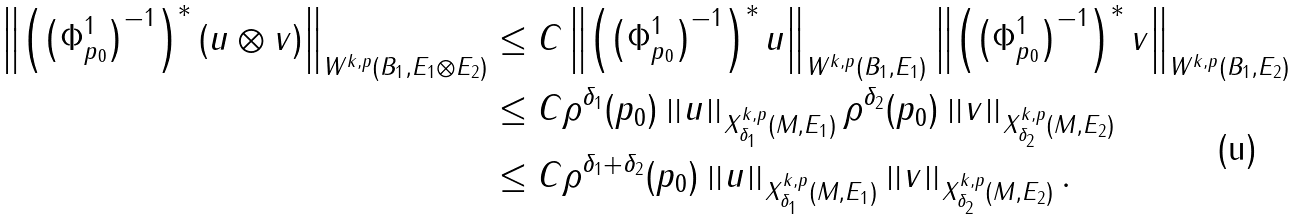<formula> <loc_0><loc_0><loc_500><loc_500>\left \| \left ( \left ( \Phi ^ { 1 } _ { p _ { 0 } } \right ) ^ { - 1 } \right ) ^ { * } ( u \otimes v ) \right \| _ { W ^ { k , p } ( B _ { 1 } , E _ { 1 } \otimes E _ { 2 } ) } & \leq C \left \| \left ( \left ( \Phi ^ { 1 } _ { p _ { 0 } } \right ) ^ { - 1 } \right ) ^ { * } u \right \| _ { W ^ { k , p } ( B _ { 1 } , E _ { 1 } ) } \left \| \left ( \left ( \Phi ^ { 1 } _ { p _ { 0 } } \right ) ^ { - 1 } \right ) ^ { * } v \right \| _ { W ^ { k , p } ( B _ { 1 } , E _ { 2 } ) } \\ & \leq C \rho ^ { \delta _ { 1 } } ( p _ { 0 } ) \left \| u \right \| _ { X ^ { k , p } _ { \delta _ { 1 } } ( M , E _ { 1 } ) } \rho ^ { \delta _ { 2 } } ( p _ { 0 } ) \left \| v \right \| _ { X ^ { k , p } _ { \delta _ { 2 } } ( M , E _ { 2 } ) } \\ & \leq C \rho ^ { \delta _ { 1 } + \delta _ { 2 } } ( p _ { 0 } ) \left \| u \right \| _ { X ^ { k , p } _ { \delta _ { 1 } } ( M , E _ { 1 } ) } \left \| v \right \| _ { X ^ { k , p } _ { \delta _ { 2 } } ( M , E _ { 2 } ) } . \\</formula> 